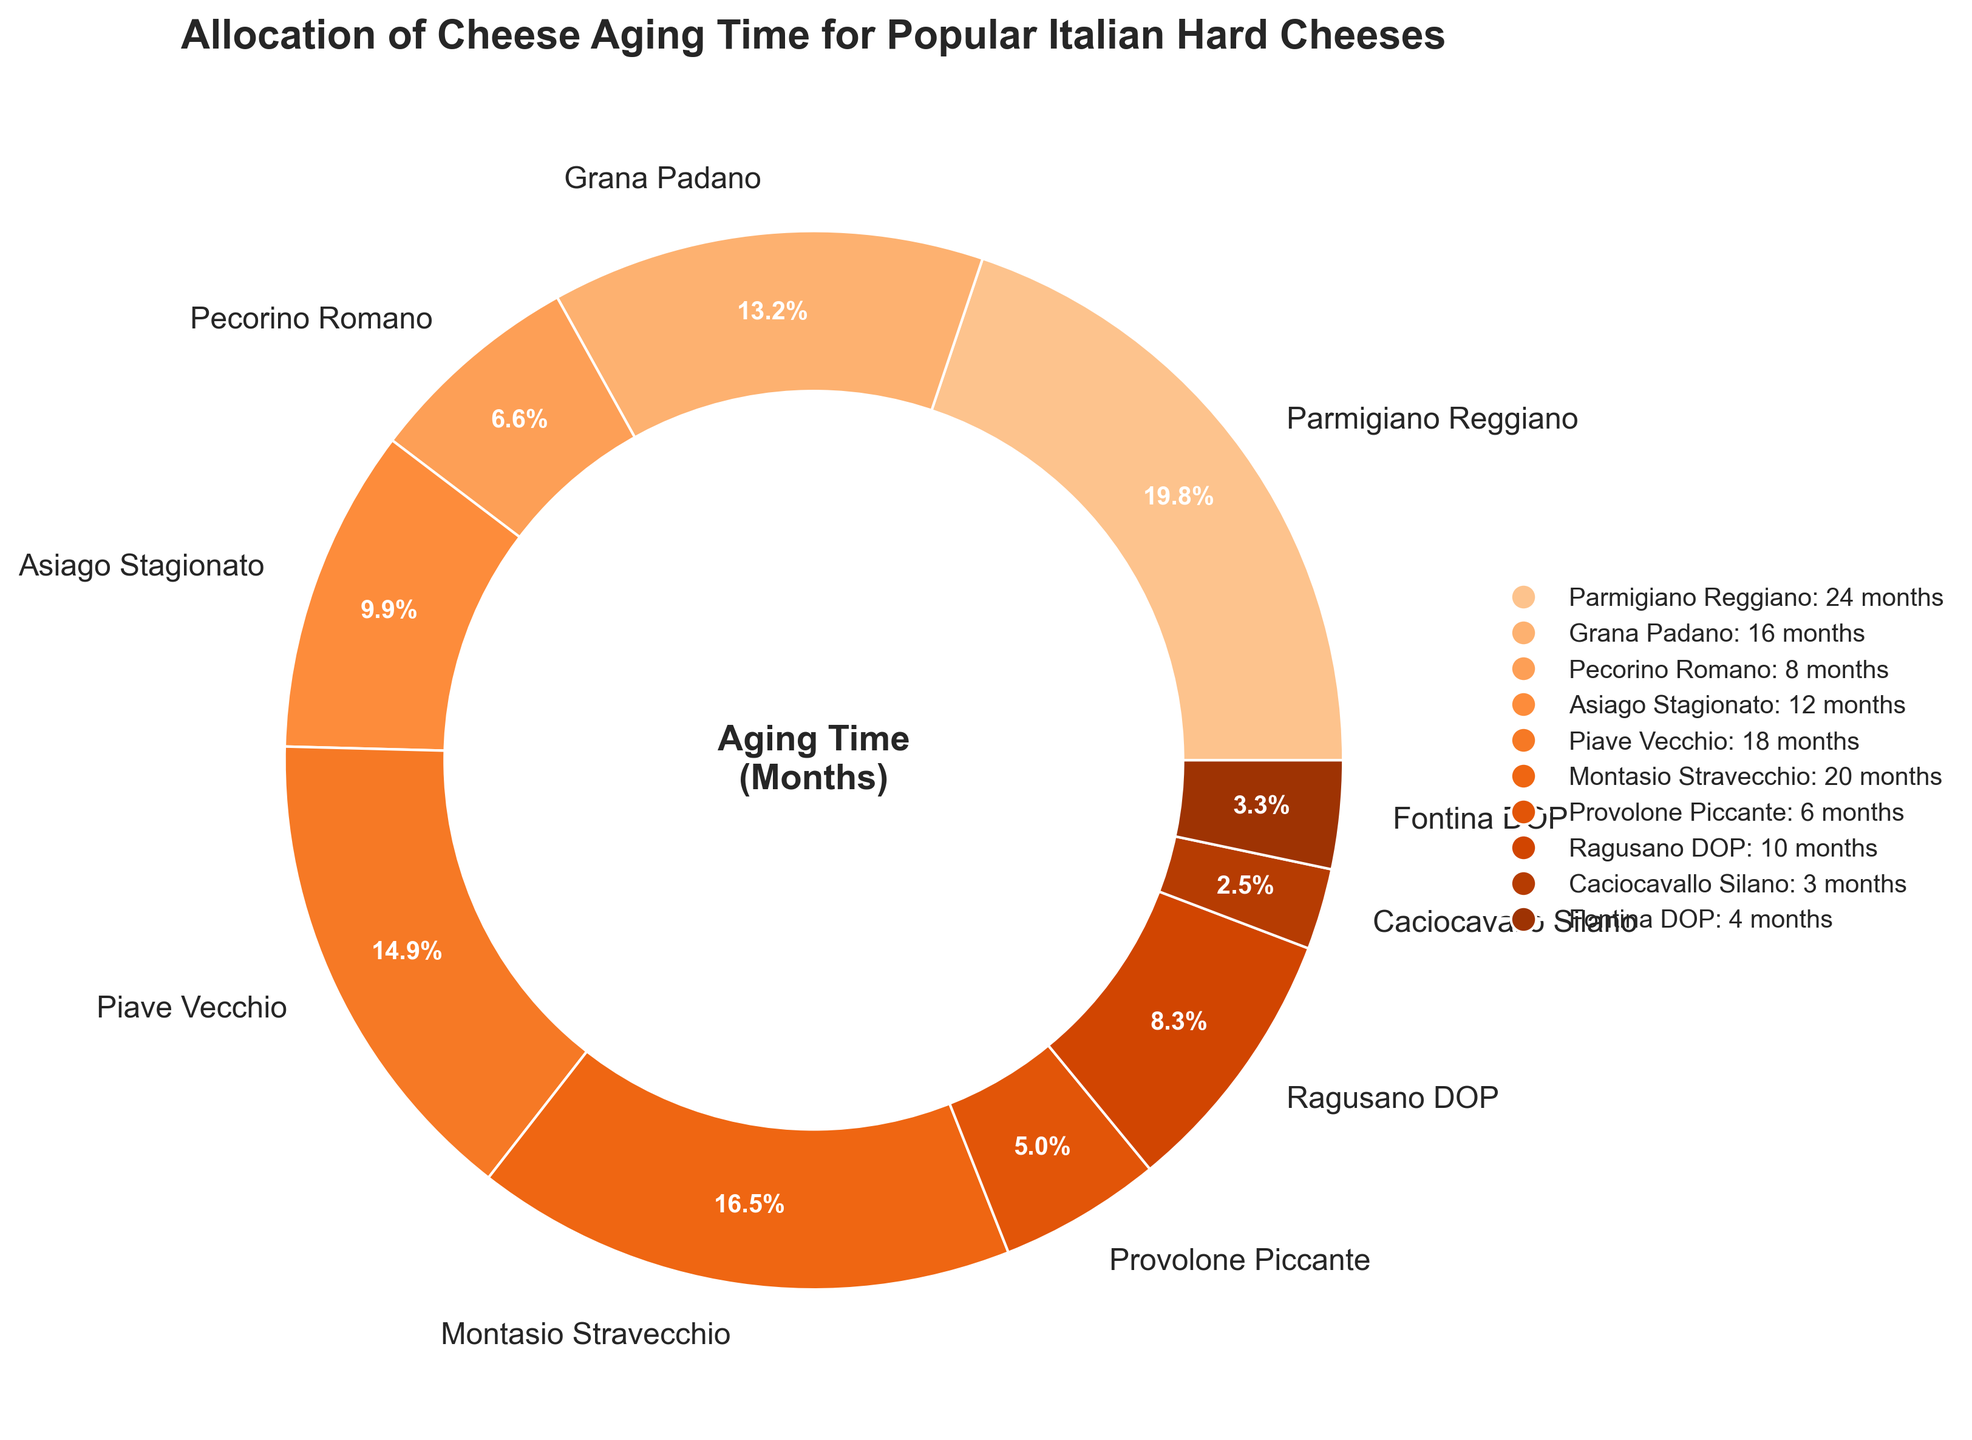Which cheese has the longest aging time? The figure shows the aging time for each cheese, and Parmigiano Reggiano has the largest percentage section.
Answer: Parmigiano Reggiano Which two cheeses have the shortest aging times? By observing the pie chart, Caciocavallo Silano and Fontina DOP have the smallest segments.
Answer: Caciocavallo Silano and Fontina DOP How much longer is the aging time of Montasio Stravecchio compared to Provolone Piccante? The chart indicates Montasio Stravecchio is aged for 20 months and Provolone Piccante for 6 months. The difference between the two is 20 - 6 = 14 months.
Answer: 14 months What is the average aging time for all listed cheeses? Sum up all the aging times: 24 + 16 + 8 + 12 + 18 + 20 + 6 + 10 + 3 + 4 = 121 months. There are 10 cheeses, so the average is 121 / 10 = 12.1 months.
Answer: 12.1 months Which cheese ages longer, Asiago Stagionato or Ragusano DOP, and by how many months? Asiago Stagionato is aged for 12 months and Ragusano DOP for 10 months. The difference is 12 - 10 = 2 months.
Answer: Asiago Stagionato, 2 months What is the total aging time for the three cheeses with the longest aging times? The three cheeses with the longest aging times are Parmigiano Reggiano (24), Montasio Stravecchio (20), and Piave Vecchio (18). The total is 24 + 20 + 18 = 62 months.
Answer: 62 months Is the aging time of Pecorino Romano longer than that of Provolone Piccante? The chart shows that Pecorino Romano has an aging time of 8 months, while Provolone Piccante has 6 months. 8 > 6.
Answer: Yes What percentage of the total aging time is allocated to Grana Padano? Grana Padano is aged for 16 months; the total aging time for all cheeses is 121 months. The percentage is (16 / 121) * 100, which is approximately 13.2%.
Answer: 13.2% Which cheese that ages more than 15 months has the smallest percentage share? From the chart, the cheeses aged more than 15 months are Parmigiano Reggiano, Grana Padano, Piave Vecchio, and Montasio Stravecchio. Among these, Grana Padano has the smallest percentage share.
Answer: Grana Padano 